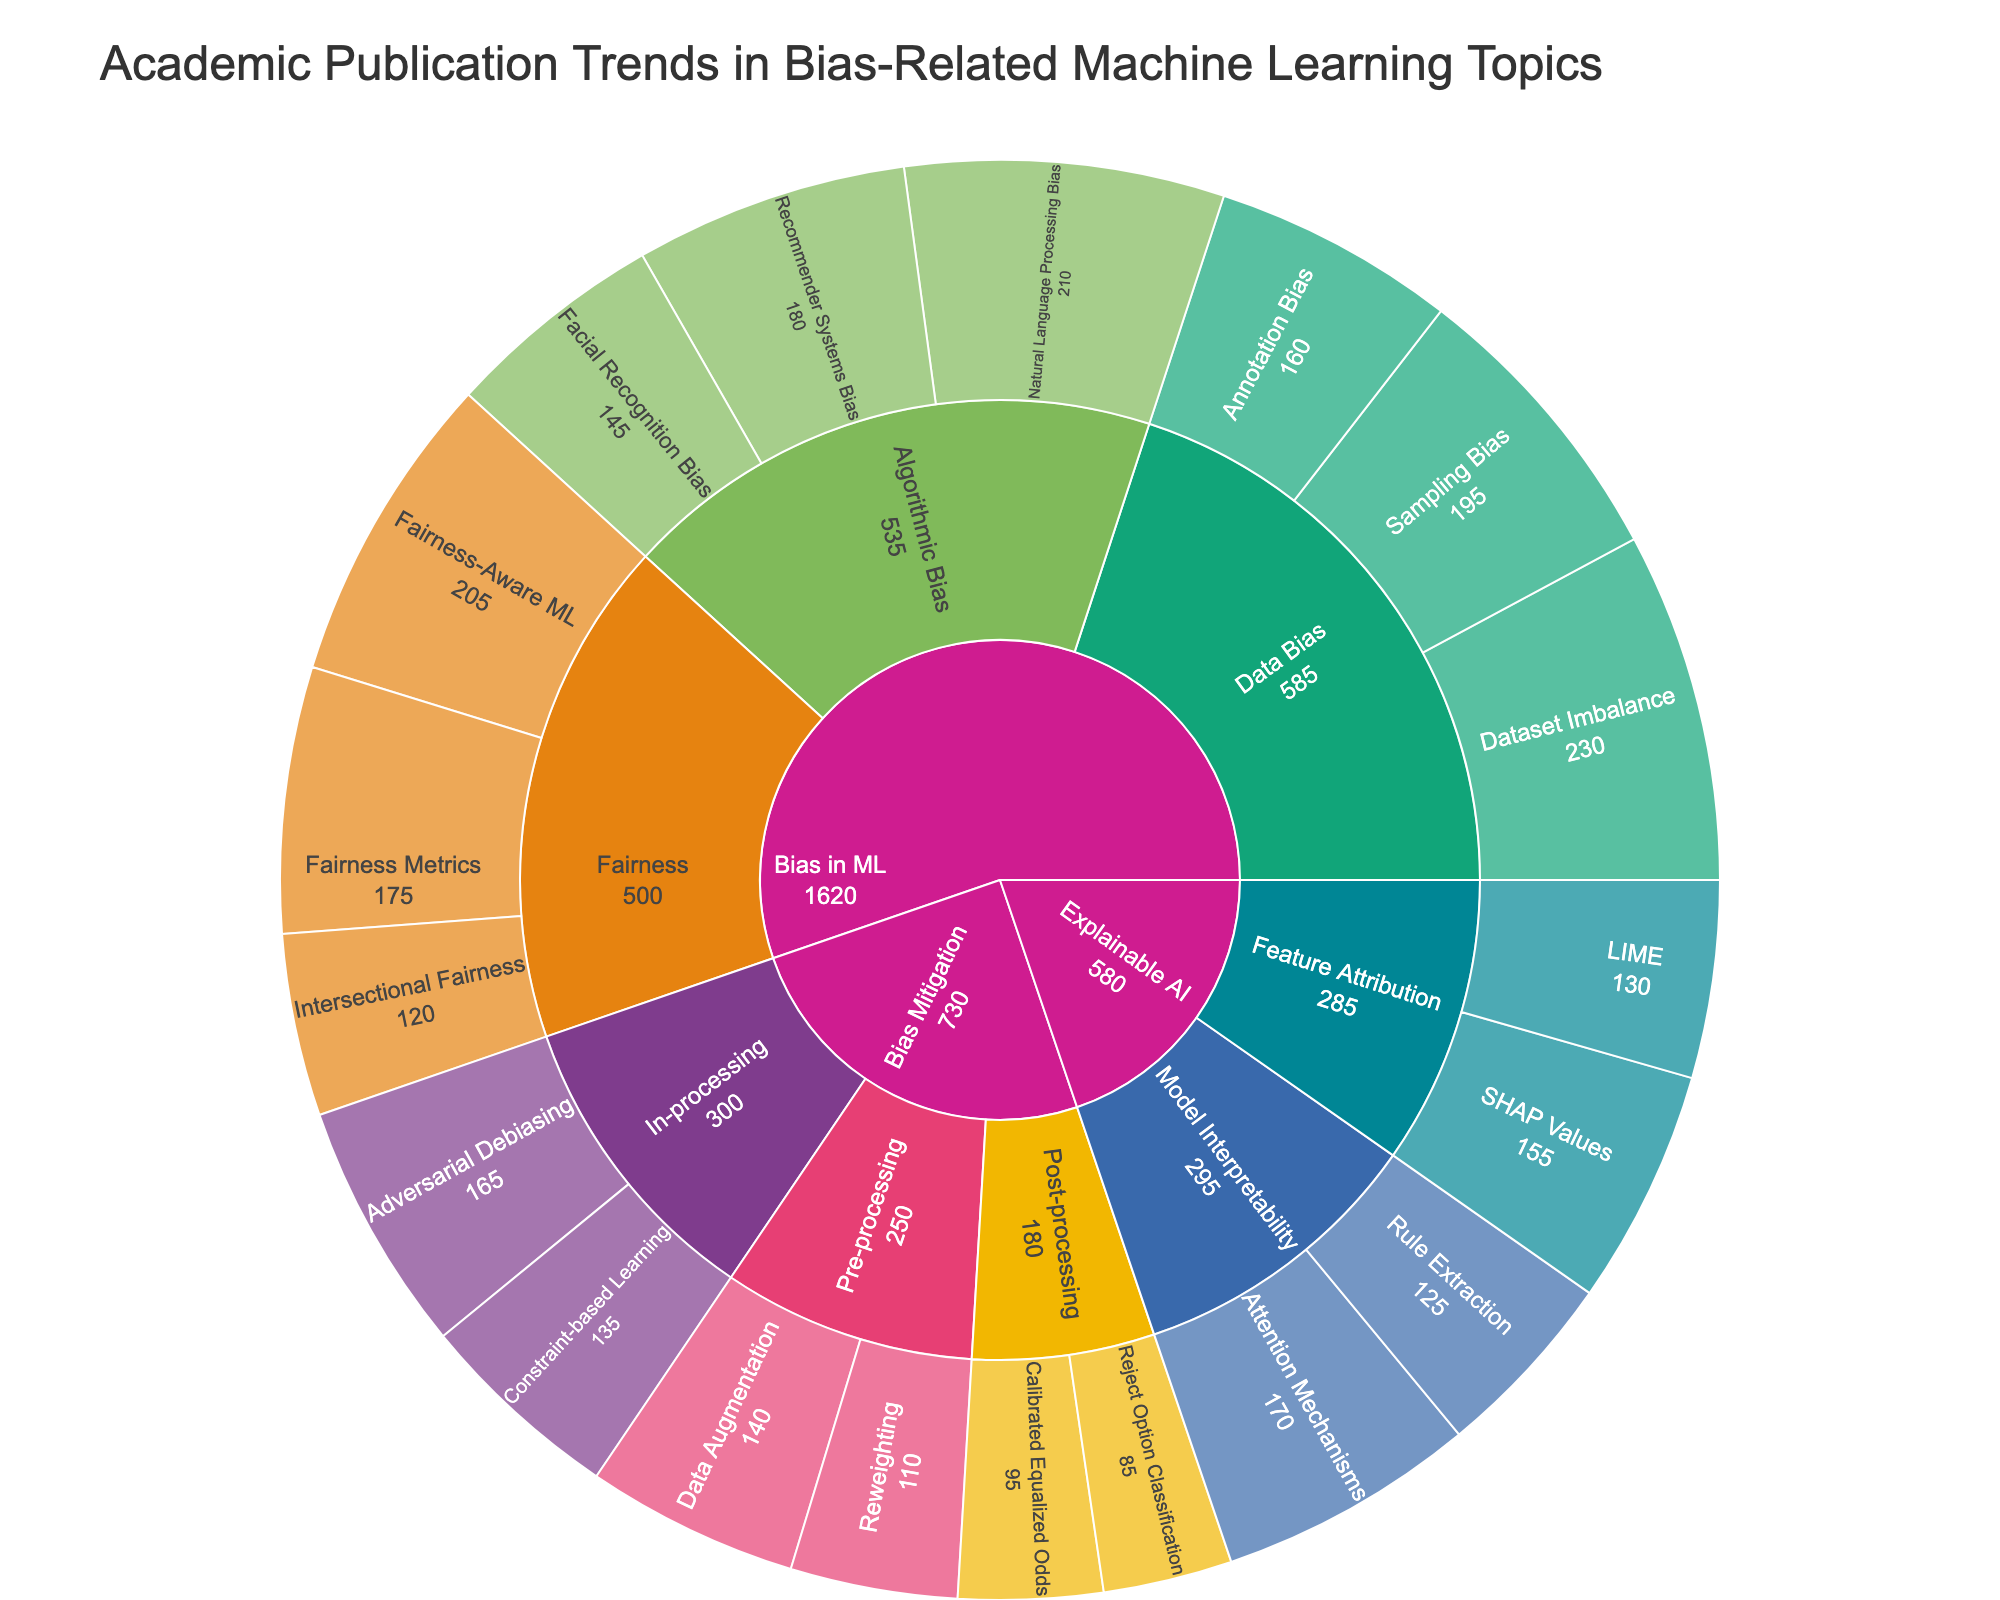What is the total number of publications for the category "Bias in ML"? Sum the publications for all subcategories under "Bias in ML". The total is 145 + 210 + 180 + 230 + 195 + 160 + 175 + 205 + 120 = 1620
Answer: 1620 Which subcategory under "Bias in ML" has the highest number of publications? Compare the total publications for each subcategory under "Bias in ML": Algorithmic Bias (145 + 210 + 180 = 535), Data Bias (230 + 195 + 160 = 585), and Fairness (175 + 205 + 120 = 500). Data Bias has the highest number of publications (585)
Answer: Data Bias How many more publications does "Data Bias" have compared to "Fairness"? Calculate the difference between total publications in "Data Bias" (585) and "Fairness" (500). The difference is 585 - 500 = 85
Answer: 85 Which topic has the fewest publications? Identify the topic with the lowest number in the "Publications" category. "Reject Option Classification" under "Post-processing" in "Bias Mitigation" has the fewest with 85 publications
Answer: Reject Option Classification What is the combined total of publications under the subcategory "Pre-processing" in "Bias Mitigation"? Add the publications for "Data Augmentation" (140) and "Reweighting" (110) under "Pre-processing". The combined total is 140 + 110 = 250
Answer: 250 Which has more publications, "SHAP Values" under "Explainable AI" or "Constraint-based Learning" under "Bias Mitigation"? Compare publications: "SHAP Values" has 155 publications and "Constraint-based Learning" has 135 publications. "SHAP Values" has more publications
Answer: SHAP Values How many topics are under the subcategory "Algorithmic Bias"? Count the distinct topics listed under the subcategory "Algorithmic Bias": Facial Recognition Bias, Natural Language Processing Bias, Recommender Systems Bias. There are 3 topics
Answer: 3 What's the average number of publications for topics under "In-processing" in "Bias Mitigation"? Calculate the average of publications for "Adversarial Debiasing" (165) and "Constraint-based Learning" (135). The average is (165 + 135) / 2 = 150
Answer: 150 Which subcategory under "Explainable AI" has a higher total number of publications, "Feature Attribution" or "Model Interpretability"? Compare totals: "Feature Attribution" (155 + 130 = 285) and "Model Interpretability" (170 + 125 = 295). "Model Interpretability" has a higher total with 295 publications
Answer: Model Interpretability 